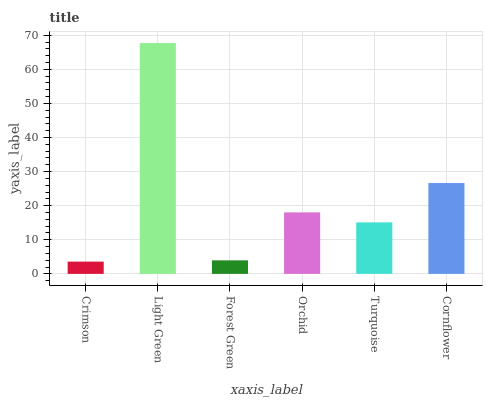Is Crimson the minimum?
Answer yes or no. Yes. Is Light Green the maximum?
Answer yes or no. Yes. Is Forest Green the minimum?
Answer yes or no. No. Is Forest Green the maximum?
Answer yes or no. No. Is Light Green greater than Forest Green?
Answer yes or no. Yes. Is Forest Green less than Light Green?
Answer yes or no. Yes. Is Forest Green greater than Light Green?
Answer yes or no. No. Is Light Green less than Forest Green?
Answer yes or no. No. Is Orchid the high median?
Answer yes or no. Yes. Is Turquoise the low median?
Answer yes or no. Yes. Is Forest Green the high median?
Answer yes or no. No. Is Forest Green the low median?
Answer yes or no. No. 